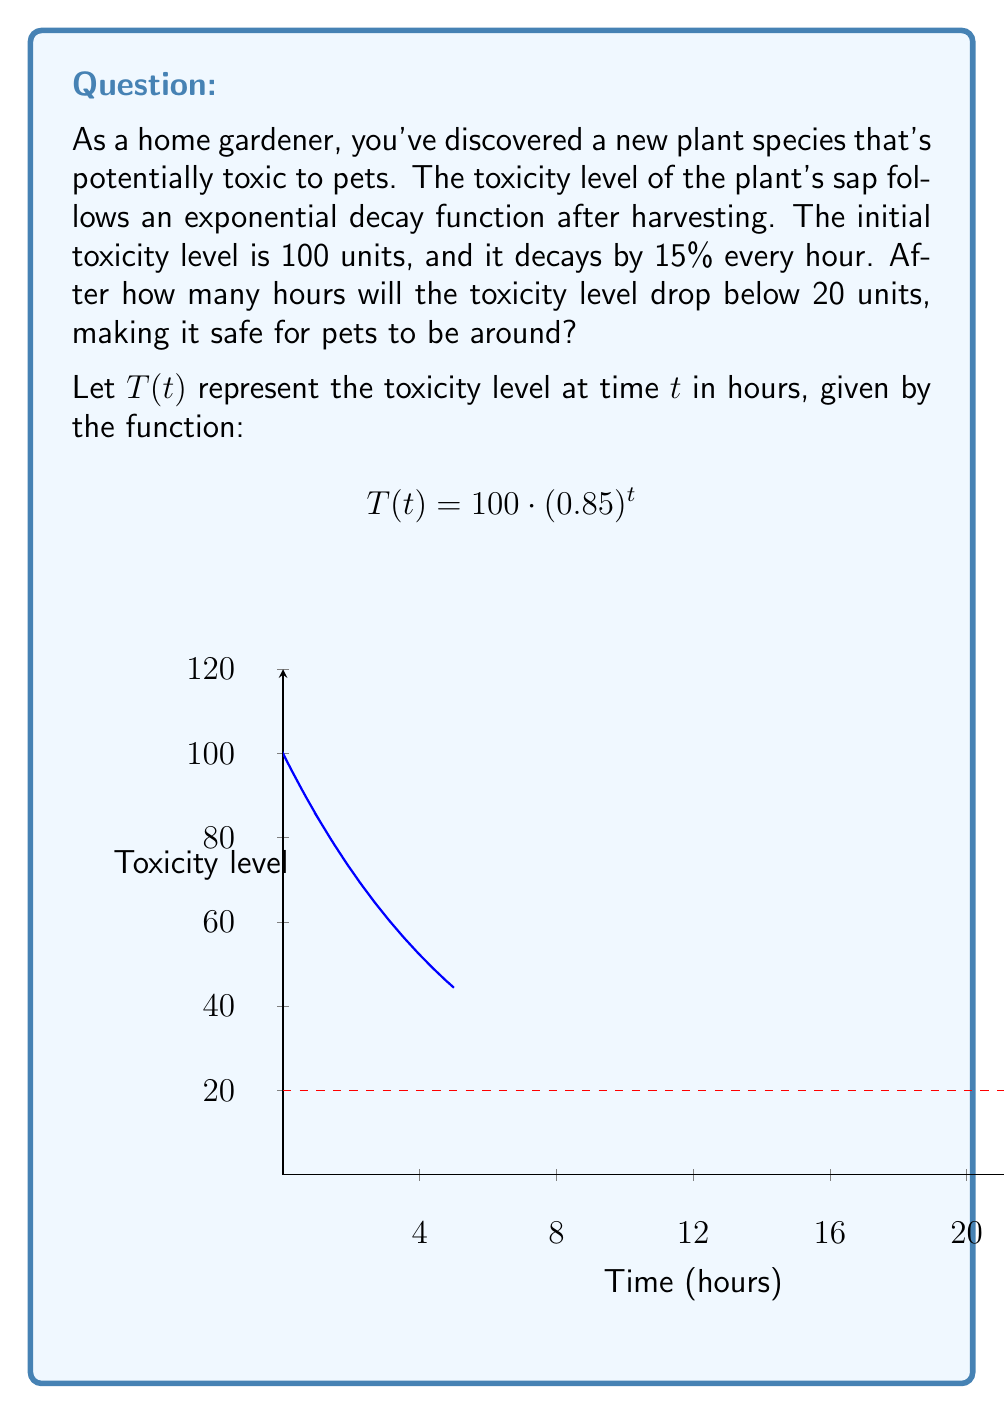Teach me how to tackle this problem. To solve this problem, we need to find the time $t$ when the toxicity level $T(t)$ becomes less than 20 units.

1) We start with the equation:
   $$T(t) = 100 \cdot (0.85)^t < 20$$

2) Divide both sides by 100:
   $$(0.85)^t < 0.2$$

3) Take the natural logarithm of both sides:
   $$t \cdot \ln(0.85) < \ln(0.2)$$

4) Divide both sides by $\ln(0.85)$ (note that $\ln(0.85)$ is negative, so the inequality sign flips):
   $$t > \frac{\ln(0.2)}{\ln(0.85)}$$

5) Calculate the right-hand side:
   $$t > \frac{\ln(0.2)}{\ln(0.85)} \approx 10.9755$$

6) Since we're looking for the number of hours, which must be a whole number, we round up to the next integer.

Therefore, after 11 hours, the toxicity level will drop below 20 units, making it safe for pets to be around.
Answer: 11 hours 